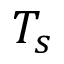<formula> <loc_0><loc_0><loc_500><loc_500>T _ { s }</formula> 